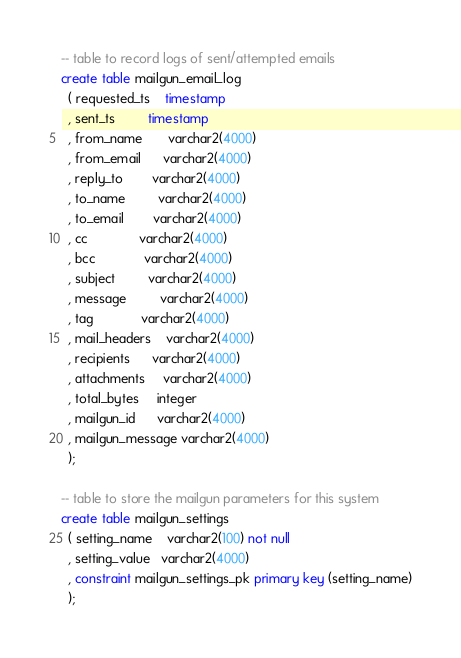<code> <loc_0><loc_0><loc_500><loc_500><_SQL_>
-- table to record logs of sent/attempted emails
create table mailgun_email_log
  ( requested_ts    timestamp
  , sent_ts         timestamp
  , from_name       varchar2(4000)
  , from_email      varchar2(4000)
  , reply_to        varchar2(4000)
  , to_name         varchar2(4000)
  , to_email        varchar2(4000)
  , cc              varchar2(4000)
  , bcc             varchar2(4000)
  , subject         varchar2(4000)
  , message         varchar2(4000)
  , tag             varchar2(4000)
  , mail_headers    varchar2(4000)
  , recipients      varchar2(4000)
  , attachments     varchar2(4000)
  , total_bytes     integer
  , mailgun_id      varchar2(4000)
  , mailgun_message varchar2(4000)
  );

-- table to store the mailgun parameters for this system
create table mailgun_settings
  ( setting_name    varchar2(100) not null
  , setting_value   varchar2(4000)
  , constraint mailgun_settings_pk primary key (setting_name)
  );</code> 